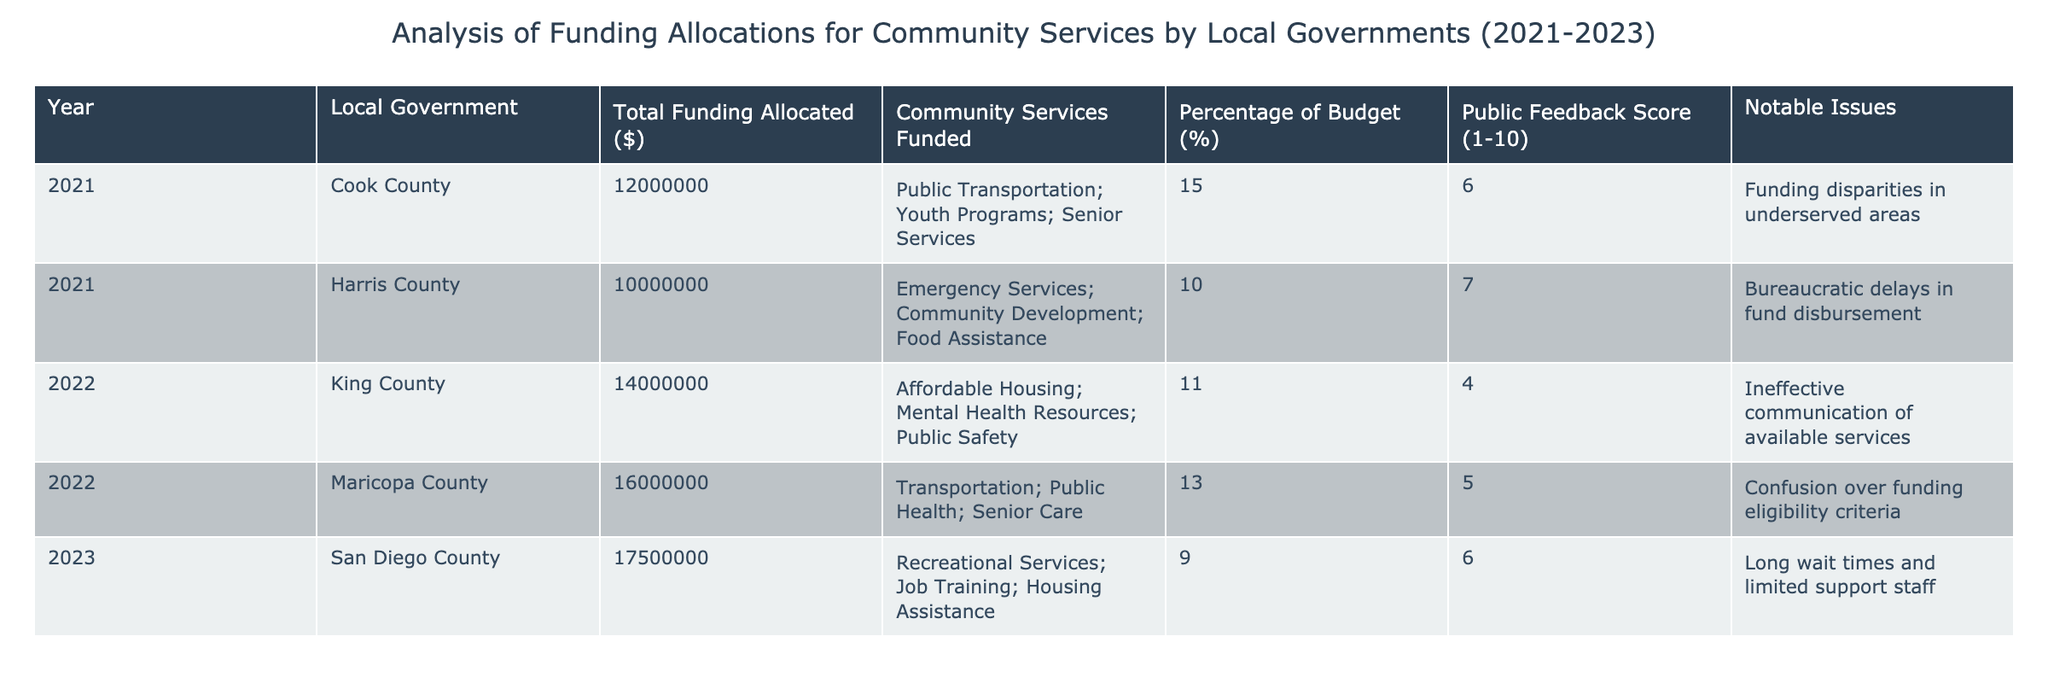What's the total funding allocated by Cook County in 2021? The table shows that in 2021, Cook County had a total funding allocation of $12,000,000.
Answer: 12,000,000 Which local government received the highest funding in 2022? In 2022, Maricopa County received the highest funding allocation, totaling $16,000,000.
Answer: Maricopa County What is the percentage of the budget allocated for community services by Harris County in 2021? The table states that Harris County allocated 10% of its budget for community services in 2021.
Answer: 10% Did King County receive more funding than Cook County in 2022? Yes, King County's funding for 2022 was $14,000,000, which is more than Cook County's $12,000,000 in 2021.
Answer: Yes What was the average public feedback score across all local governments in 2021? The public feedback scores for 2021 are 6 (Cook County) and 7 (Harris County). The average is (6 + 7) / 2 = 6.5.
Answer: 6.5 What notable issue was reported by San Diego County in 2023? The table notes that San Diego County's notable issue in 2023 was "long wait times and limited support staff."
Answer: Long wait times and limited support staff How much more funding was allocated to Maricopa County compared to King County in 2022? Maricopa County's funding in 2022 was $16,000,000 and King County's was $14,000,000. The difference is $16,000,000 - $14,000,000 = $2,000,000.
Answer: 2,000,000 Was there a community service funded by both Harris County in 2021 and King County in 2022? No, the community services funded in Harris County included Emergency Services, Community Development, and Food Assistance, while King County funded Affordable Housing, Mental Health Resources, and Public Safety, showing no overlap.
Answer: No What is the overall trend in funding allocation from 2021 to 2023? The table indicates that funding allocation increased from $12,000,000 in 2021 (Cook County) to $17,500,000 in 2023 (San Diego County), suggesting a rising trend in funding over these years.
Answer: Rising trend 